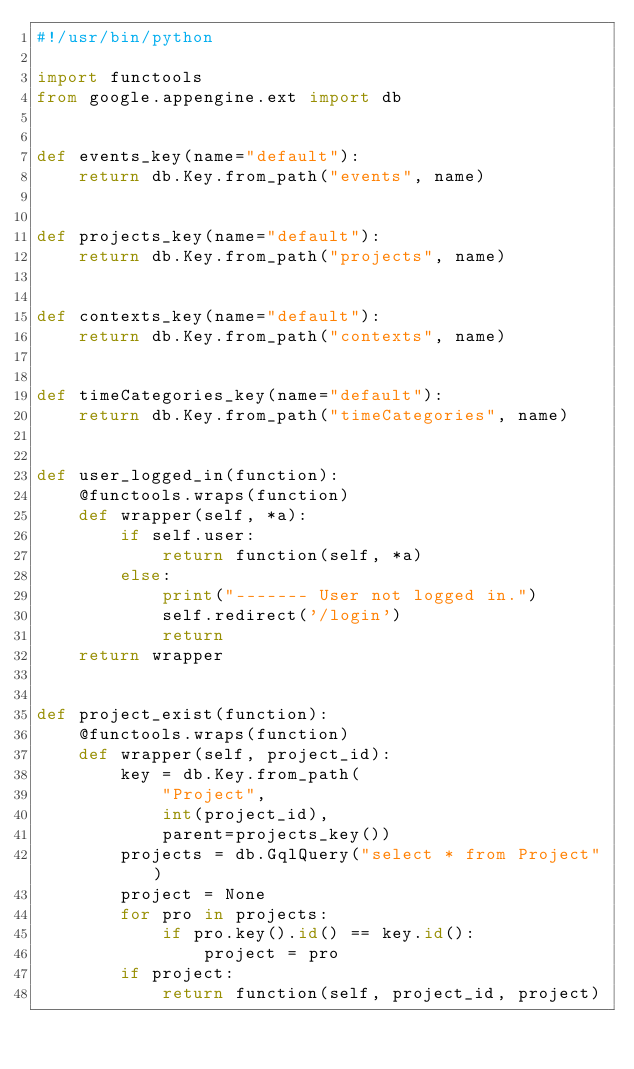Convert code to text. <code><loc_0><loc_0><loc_500><loc_500><_Python_>#!/usr/bin/python

import functools
from google.appengine.ext import db


def events_key(name="default"):
    return db.Key.from_path("events", name)


def projects_key(name="default"):
    return db.Key.from_path("projects", name)


def contexts_key(name="default"):
    return db.Key.from_path("contexts", name)


def timeCategories_key(name="default"):
    return db.Key.from_path("timeCategories", name)


def user_logged_in(function):
    @functools.wraps(function)
    def wrapper(self, *a):
        if self.user:
            return function(self, *a)
        else:
            print("------- User not logged in.")
            self.redirect('/login')
            return
    return wrapper


def project_exist(function):
    @functools.wraps(function)
    def wrapper(self, project_id):
        key = db.Key.from_path(
            "Project",
            int(project_id),
            parent=projects_key())
        projects = db.GqlQuery("select * from Project")
        project = None
        for pro in projects:
            if pro.key().id() == key.id():
                project = pro
        if project:
            return function(self, project_id, project)</code> 